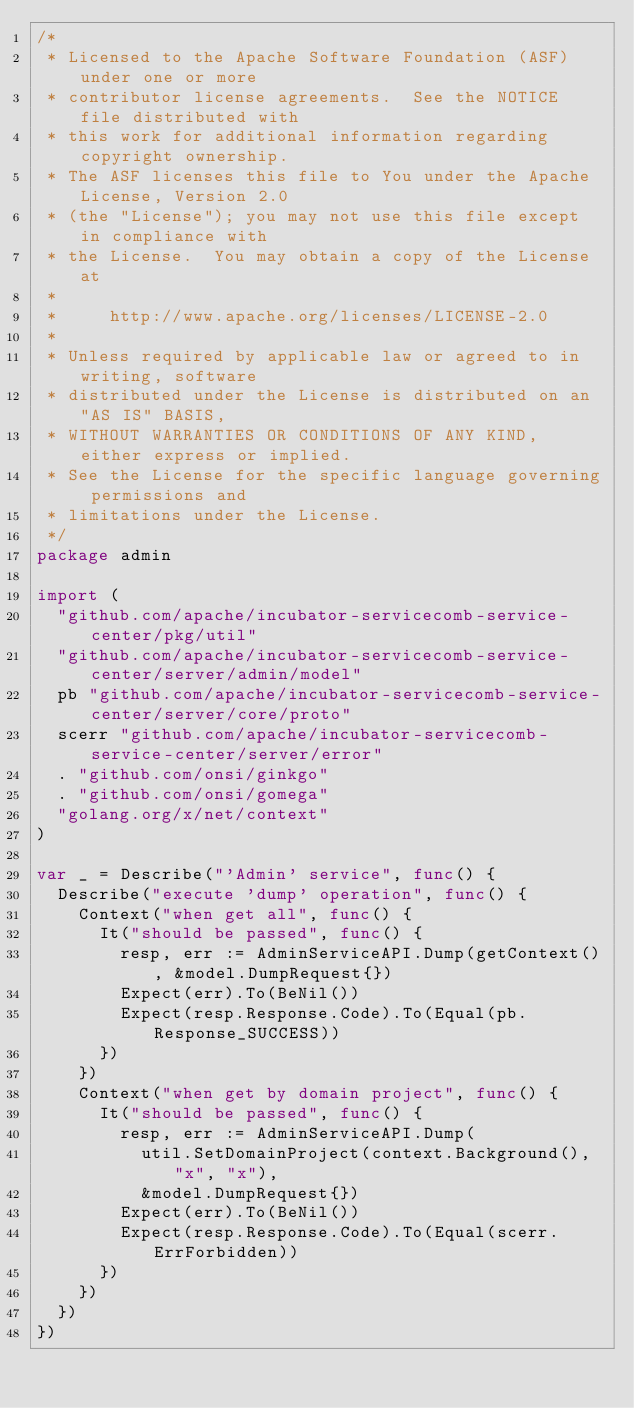Convert code to text. <code><loc_0><loc_0><loc_500><loc_500><_Go_>/*
 * Licensed to the Apache Software Foundation (ASF) under one or more
 * contributor license agreements.  See the NOTICE file distributed with
 * this work for additional information regarding copyright ownership.
 * The ASF licenses this file to You under the Apache License, Version 2.0
 * (the "License"); you may not use this file except in compliance with
 * the License.  You may obtain a copy of the License at
 *
 *     http://www.apache.org/licenses/LICENSE-2.0
 *
 * Unless required by applicable law or agreed to in writing, software
 * distributed under the License is distributed on an "AS IS" BASIS,
 * WITHOUT WARRANTIES OR CONDITIONS OF ANY KIND, either express or implied.
 * See the License for the specific language governing permissions and
 * limitations under the License.
 */
package admin

import (
	"github.com/apache/incubator-servicecomb-service-center/pkg/util"
	"github.com/apache/incubator-servicecomb-service-center/server/admin/model"
	pb "github.com/apache/incubator-servicecomb-service-center/server/core/proto"
	scerr "github.com/apache/incubator-servicecomb-service-center/server/error"
	. "github.com/onsi/ginkgo"
	. "github.com/onsi/gomega"
	"golang.org/x/net/context"
)

var _ = Describe("'Admin' service", func() {
	Describe("execute 'dump' operation", func() {
		Context("when get all", func() {
			It("should be passed", func() {
				resp, err := AdminServiceAPI.Dump(getContext(), &model.DumpRequest{})
				Expect(err).To(BeNil())
				Expect(resp.Response.Code).To(Equal(pb.Response_SUCCESS))
			})
		})
		Context("when get by domain project", func() {
			It("should be passed", func() {
				resp, err := AdminServiceAPI.Dump(
					util.SetDomainProject(context.Background(), "x", "x"),
					&model.DumpRequest{})
				Expect(err).To(BeNil())
				Expect(resp.Response.Code).To(Equal(scerr.ErrForbidden))
			})
		})
	})
})
</code> 